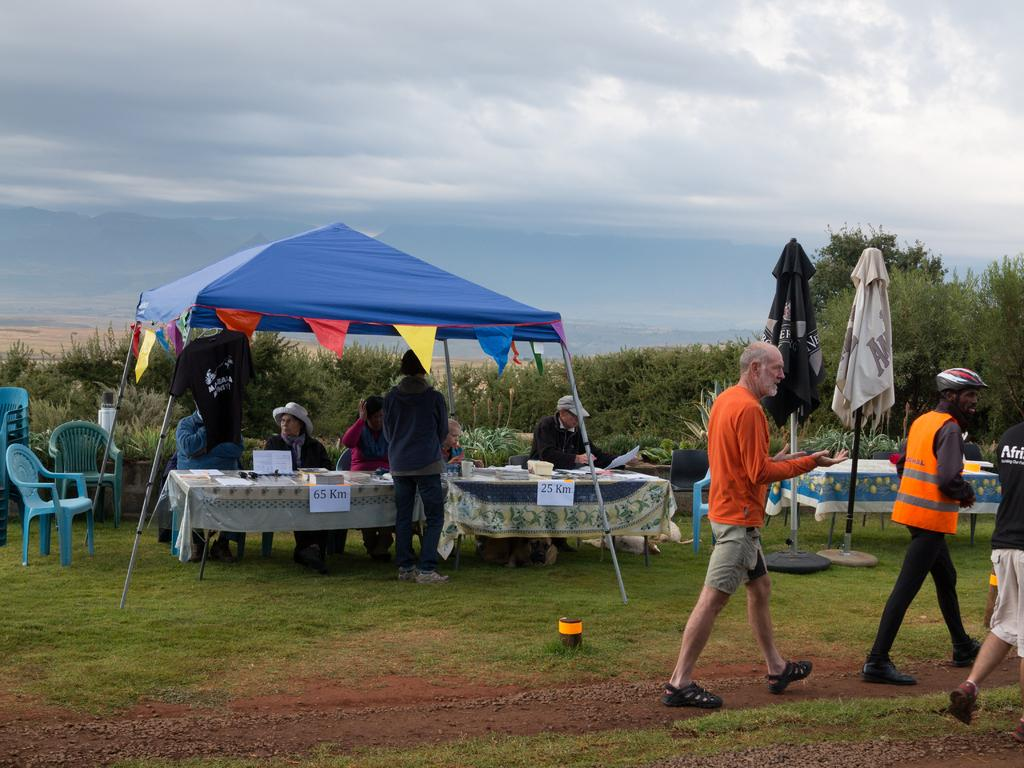What is happening on the ground in the image? There are people on the ground in the image. What type of shelter is visible in the image? There is a tent in the image. What can be seen hanging or placed on the tables in the image? Clothes are visible in the image. What type of furniture is present in the image? Tables and chairs are present in the image. What else can be seen in the image besides the people, tent, and furniture? There are objects in the image. What can be seen in the background of the image? There are trees and the sky visible in the background of the image. What type of pie is being served on the tables in the image? There is no pie present in the image; the tables have clothes hanging or placed on them. How many eggs are visible in the image? There are no eggs visible in the image. 